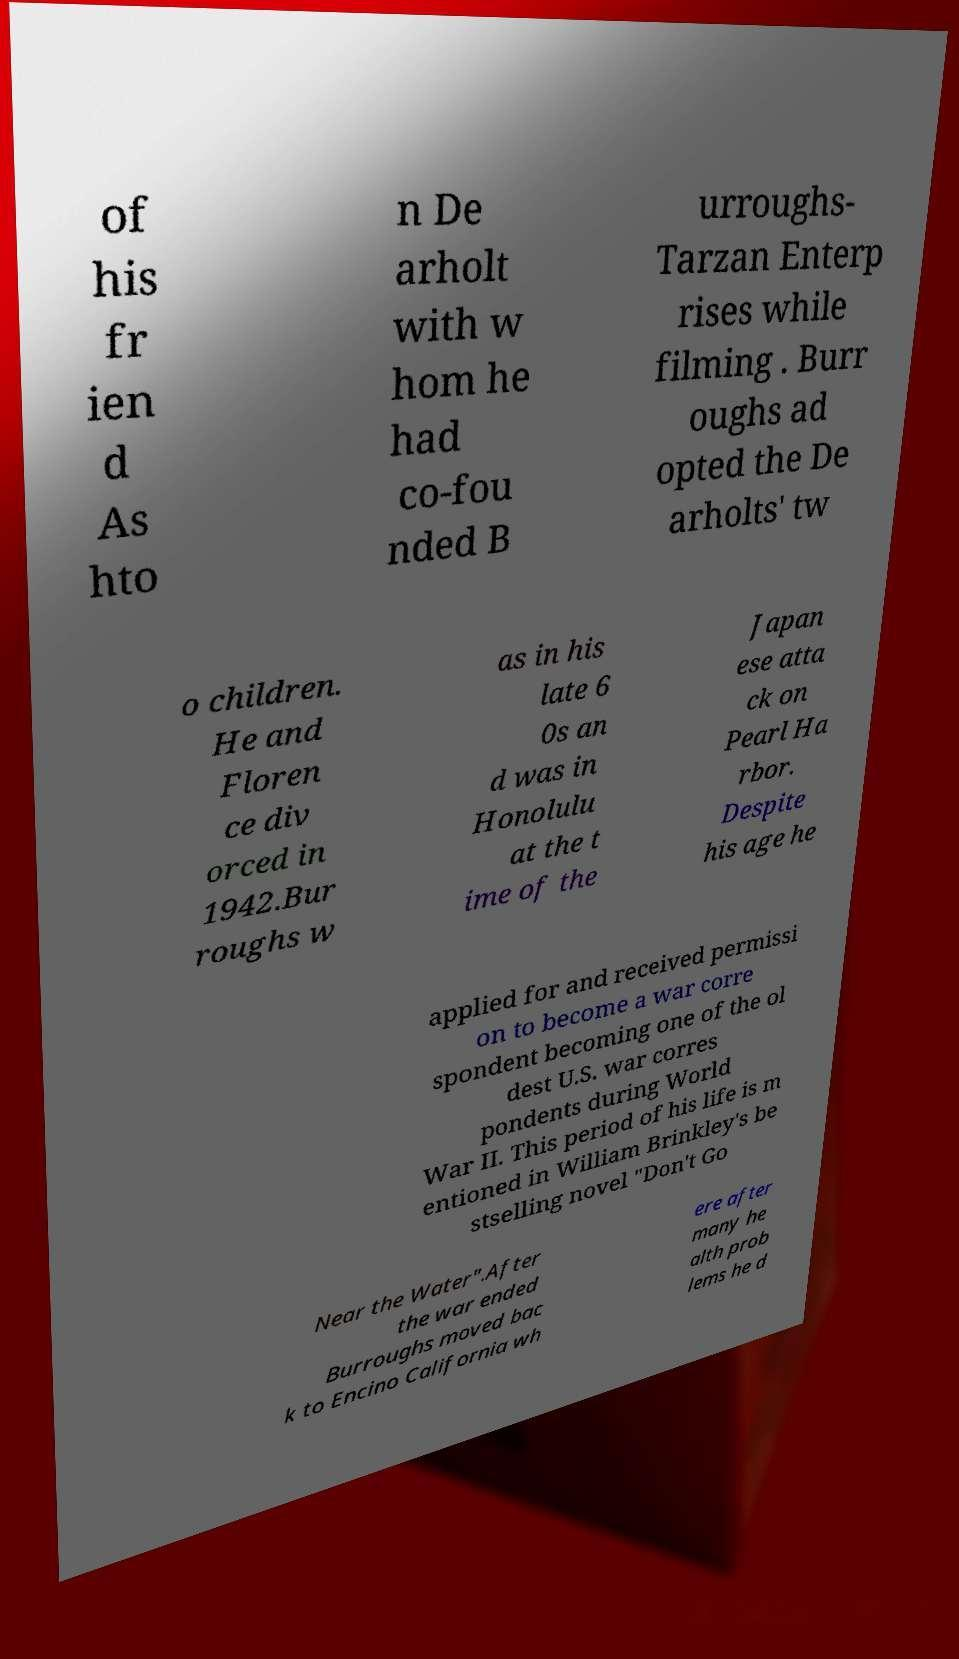There's text embedded in this image that I need extracted. Can you transcribe it verbatim? of his fr ien d As hto n De arholt with w hom he had co-fou nded B urroughs- Tarzan Enterp rises while filming . Burr oughs ad opted the De arholts' tw o children. He and Floren ce div orced in 1942.Bur roughs w as in his late 6 0s an d was in Honolulu at the t ime of the Japan ese atta ck on Pearl Ha rbor. Despite his age he applied for and received permissi on to become a war corre spondent becoming one of the ol dest U.S. war corres pondents during World War II. This period of his life is m entioned in William Brinkley's be stselling novel "Don't Go Near the Water".After the war ended Burroughs moved bac k to Encino California wh ere after many he alth prob lems he d 